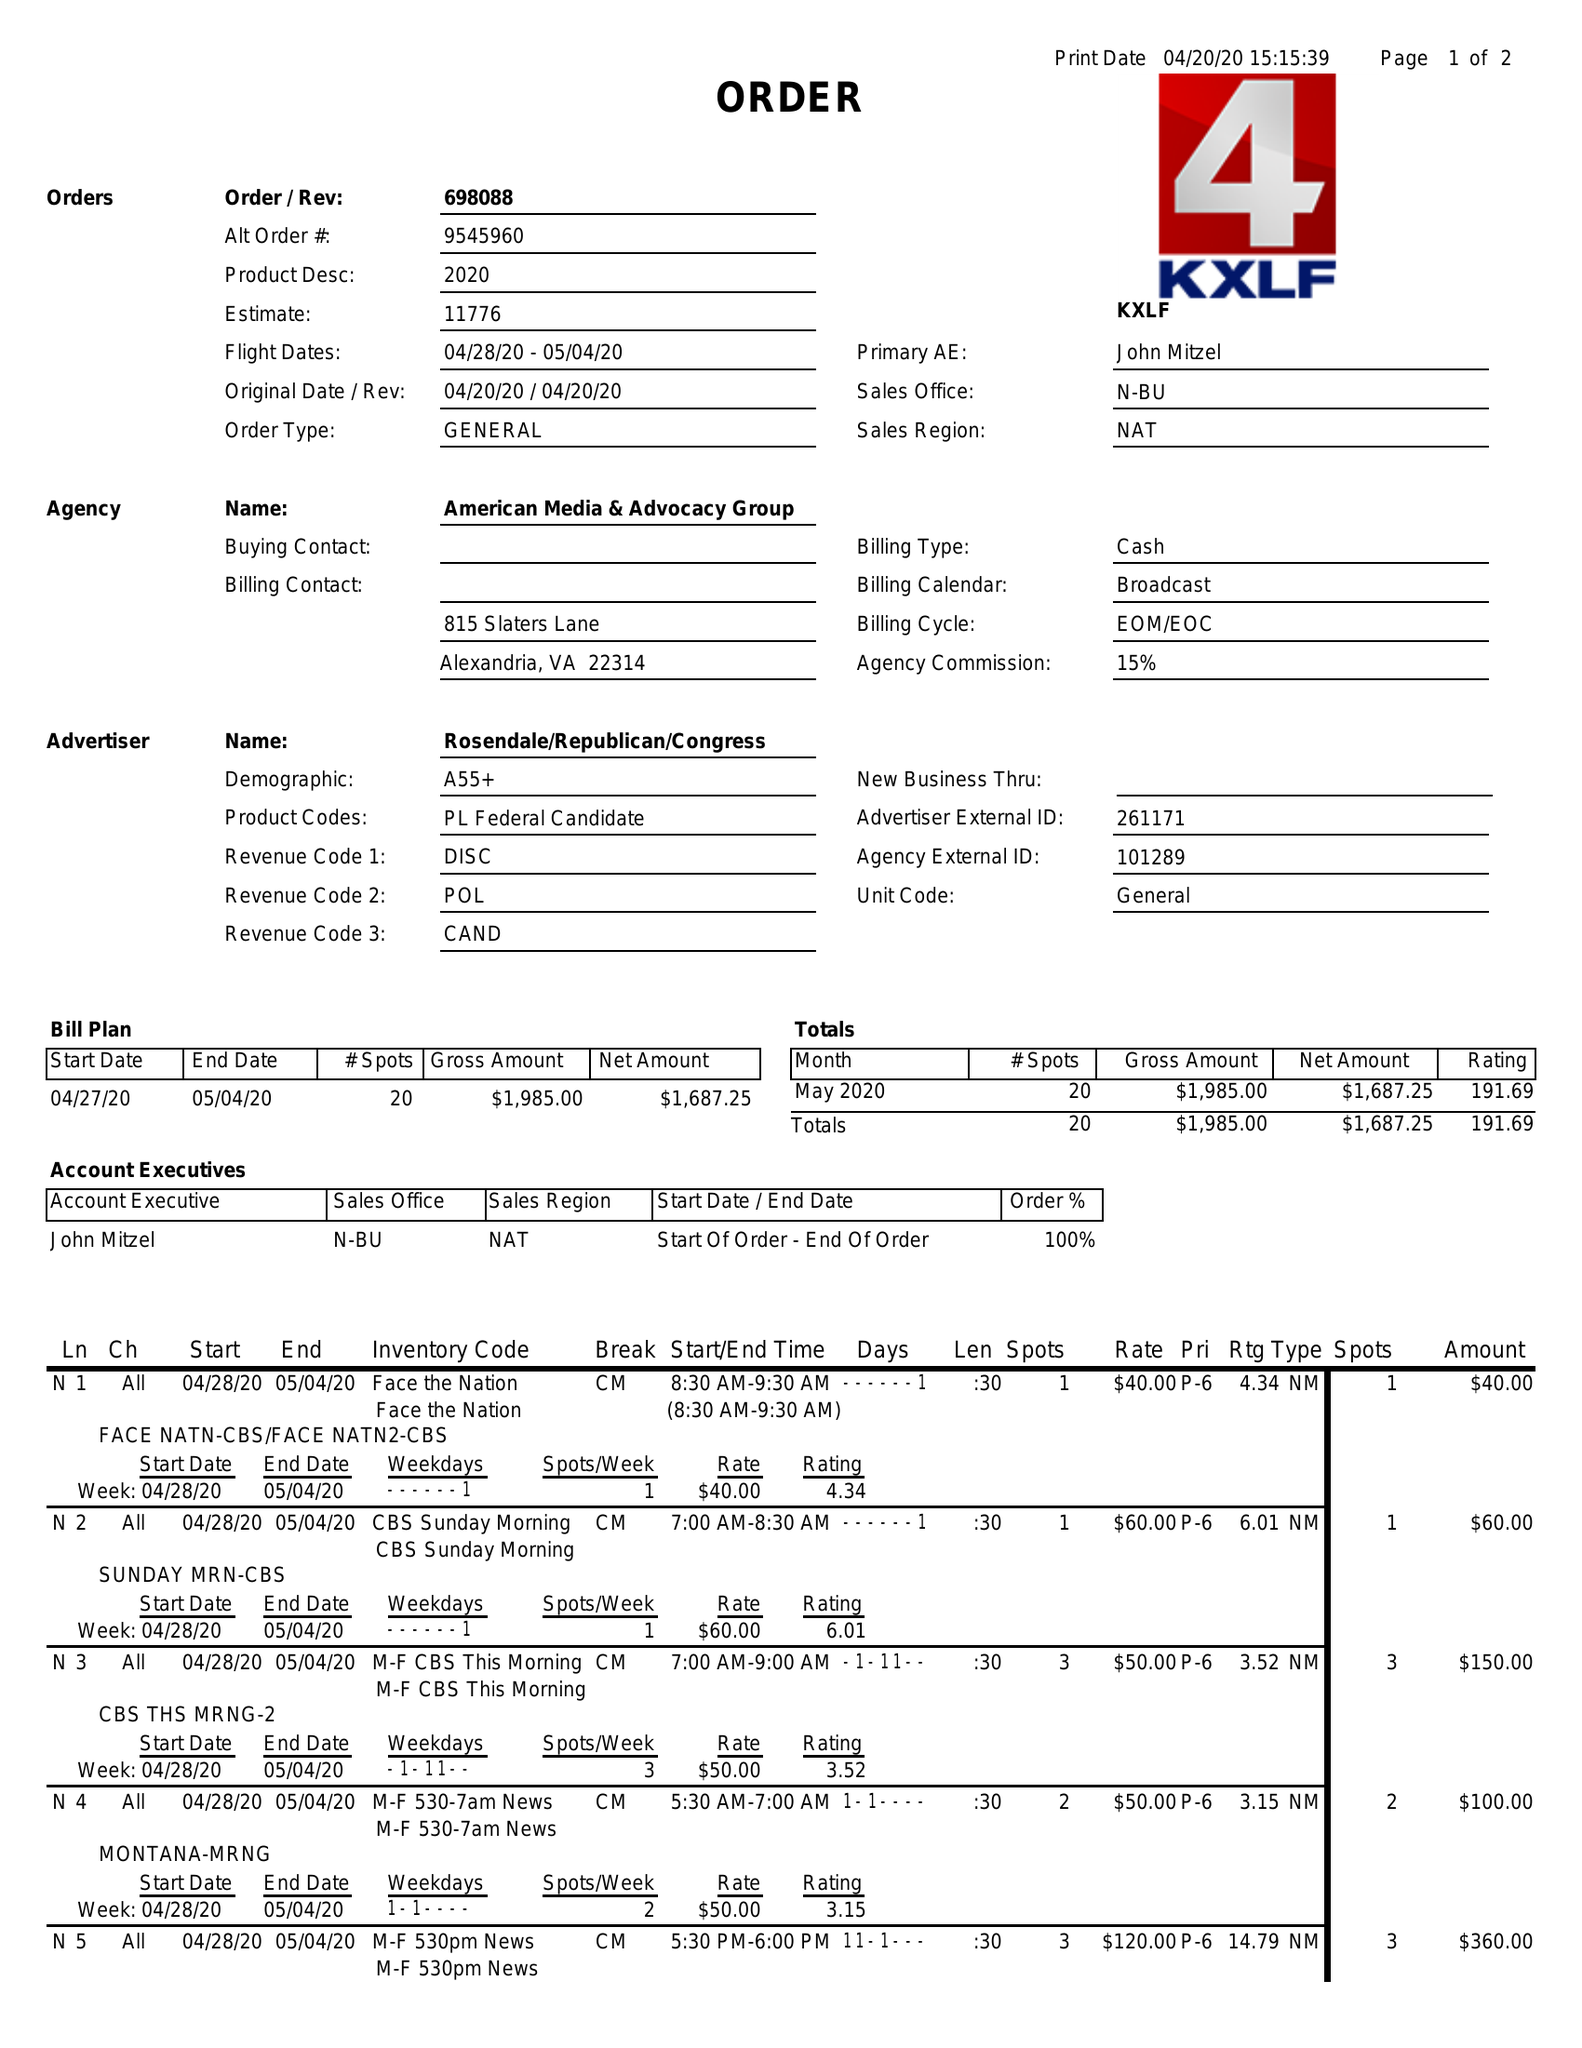What is the value for the gross_amount?
Answer the question using a single word or phrase. 1985.00 